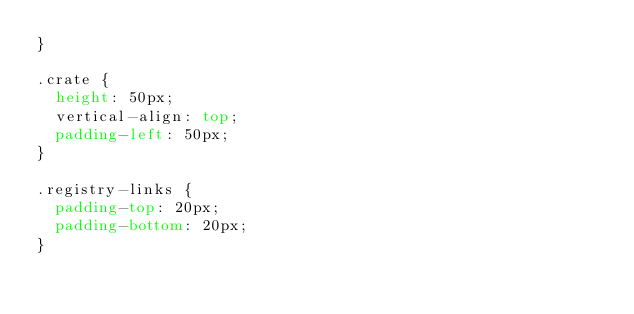<code> <loc_0><loc_0><loc_500><loc_500><_CSS_>}

.crate {
  height: 50px;
  vertical-align: top;
  padding-left: 50px;
}

.registry-links {
  padding-top: 20px;
  padding-bottom: 20px;
}

</code> 